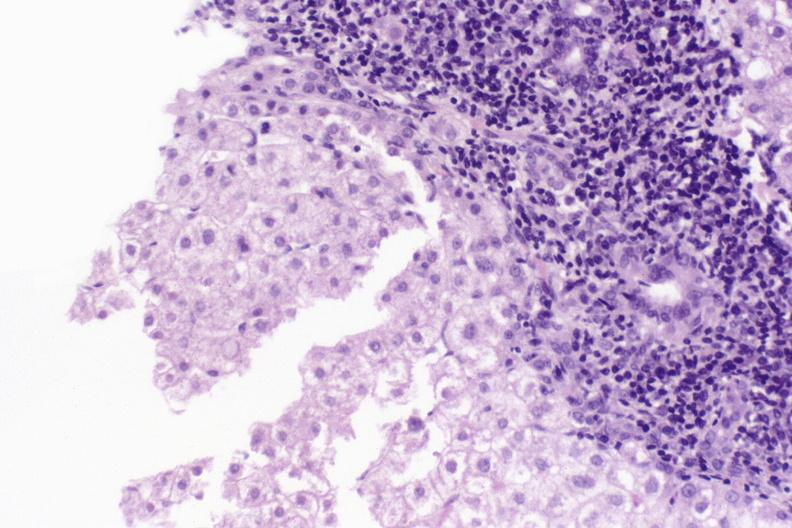what is present?
Answer the question using a single word or phrase. Liver 